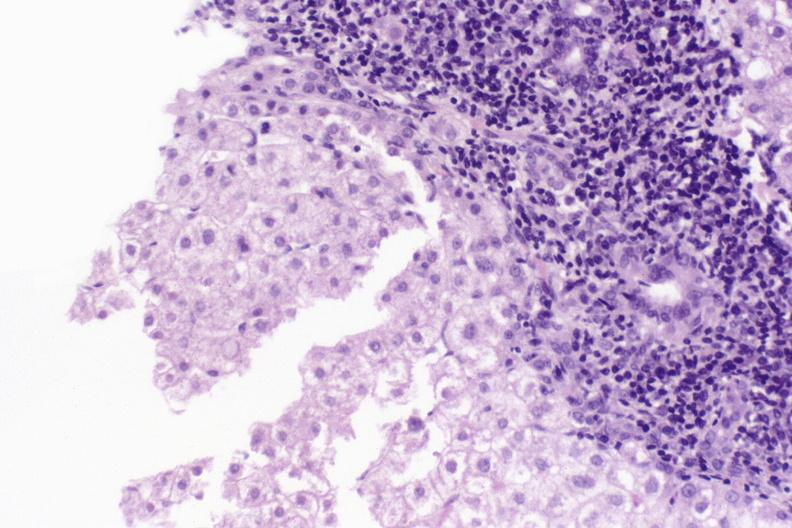what is present?
Answer the question using a single word or phrase. Liver 